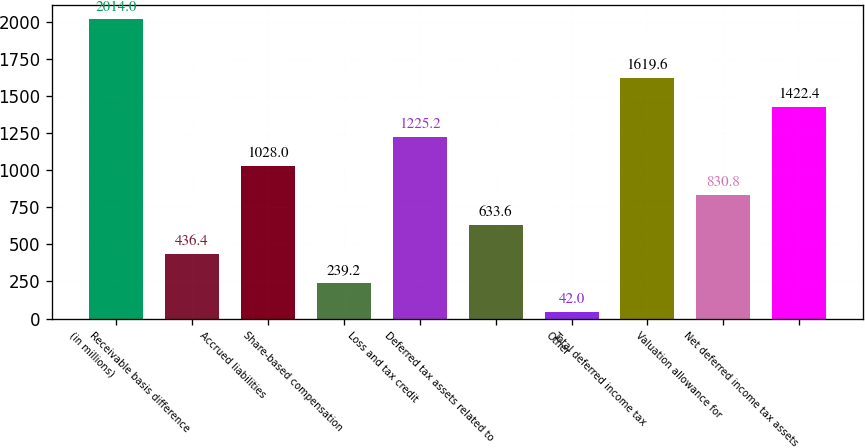Convert chart to OTSL. <chart><loc_0><loc_0><loc_500><loc_500><bar_chart><fcel>(in millions)<fcel>Receivable basis difference<fcel>Accrued liabilities<fcel>Share-based compensation<fcel>Loss and tax credit<fcel>Deferred tax assets related to<fcel>Other<fcel>Total deferred income tax<fcel>Valuation allowance for<fcel>Net deferred income tax assets<nl><fcel>2014<fcel>436.4<fcel>1028<fcel>239.2<fcel>1225.2<fcel>633.6<fcel>42<fcel>1619.6<fcel>830.8<fcel>1422.4<nl></chart> 